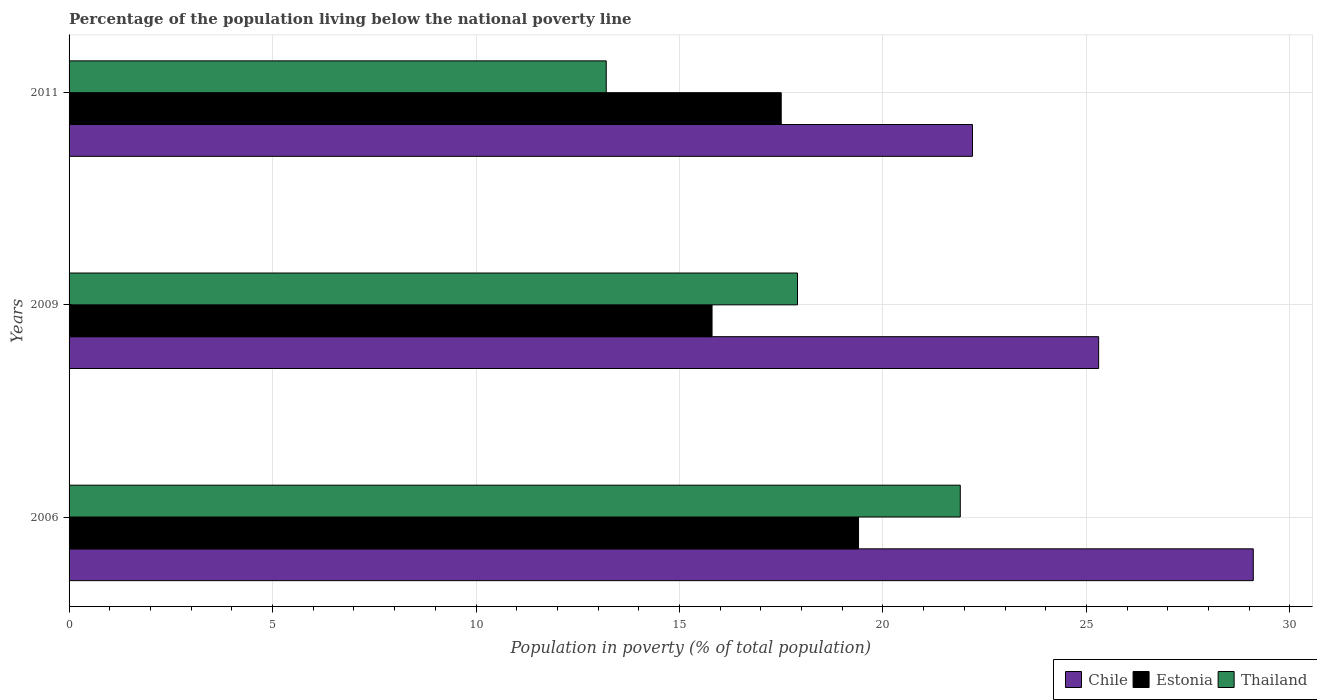How many different coloured bars are there?
Offer a terse response. 3. How many groups of bars are there?
Provide a short and direct response. 3. Are the number of bars per tick equal to the number of legend labels?
Offer a very short reply. Yes. Are the number of bars on each tick of the Y-axis equal?
Your response must be concise. Yes. How many bars are there on the 1st tick from the bottom?
Your answer should be very brief. 3. What is the label of the 1st group of bars from the top?
Your answer should be compact. 2011. In how many cases, is the number of bars for a given year not equal to the number of legend labels?
Provide a short and direct response. 0. Across all years, what is the maximum percentage of the population living below the national poverty line in Thailand?
Keep it short and to the point. 21.9. What is the total percentage of the population living below the national poverty line in Thailand in the graph?
Provide a succinct answer. 53. What is the difference between the percentage of the population living below the national poverty line in Thailand in 2006 and that in 2009?
Ensure brevity in your answer.  4. What is the difference between the percentage of the population living below the national poverty line in Thailand in 2006 and the percentage of the population living below the national poverty line in Estonia in 2011?
Provide a succinct answer. 4.4. What is the average percentage of the population living below the national poverty line in Estonia per year?
Make the answer very short. 17.57. In the year 2011, what is the difference between the percentage of the population living below the national poverty line in Chile and percentage of the population living below the national poverty line in Estonia?
Offer a very short reply. 4.7. In how many years, is the percentage of the population living below the national poverty line in Chile greater than 19 %?
Offer a terse response. 3. What is the ratio of the percentage of the population living below the national poverty line in Thailand in 2009 to that in 2011?
Offer a terse response. 1.36. Is the percentage of the population living below the national poverty line in Chile in 2006 less than that in 2011?
Give a very brief answer. No. Is the difference between the percentage of the population living below the national poverty line in Chile in 2009 and 2011 greater than the difference between the percentage of the population living below the national poverty line in Estonia in 2009 and 2011?
Offer a very short reply. Yes. What is the difference between the highest and the second highest percentage of the population living below the national poverty line in Estonia?
Your answer should be very brief. 1.9. In how many years, is the percentage of the population living below the national poverty line in Thailand greater than the average percentage of the population living below the national poverty line in Thailand taken over all years?
Provide a succinct answer. 2. What does the 1st bar from the top in 2011 represents?
Keep it short and to the point. Thailand. What does the 1st bar from the bottom in 2009 represents?
Ensure brevity in your answer.  Chile. Is it the case that in every year, the sum of the percentage of the population living below the national poverty line in Thailand and percentage of the population living below the national poverty line in Estonia is greater than the percentage of the population living below the national poverty line in Chile?
Give a very brief answer. Yes. How many bars are there?
Your response must be concise. 9. Are the values on the major ticks of X-axis written in scientific E-notation?
Your answer should be very brief. No. How are the legend labels stacked?
Keep it short and to the point. Horizontal. What is the title of the graph?
Your response must be concise. Percentage of the population living below the national poverty line. Does "Portugal" appear as one of the legend labels in the graph?
Ensure brevity in your answer.  No. What is the label or title of the X-axis?
Provide a short and direct response. Population in poverty (% of total population). What is the label or title of the Y-axis?
Your answer should be compact. Years. What is the Population in poverty (% of total population) in Chile in 2006?
Your answer should be very brief. 29.1. What is the Population in poverty (% of total population) in Thailand in 2006?
Ensure brevity in your answer.  21.9. What is the Population in poverty (% of total population) in Chile in 2009?
Provide a short and direct response. 25.3. What is the Population in poverty (% of total population) in Estonia in 2011?
Offer a terse response. 17.5. Across all years, what is the maximum Population in poverty (% of total population) of Chile?
Give a very brief answer. 29.1. Across all years, what is the maximum Population in poverty (% of total population) of Estonia?
Provide a succinct answer. 19.4. Across all years, what is the maximum Population in poverty (% of total population) of Thailand?
Ensure brevity in your answer.  21.9. Across all years, what is the minimum Population in poverty (% of total population) of Estonia?
Your answer should be very brief. 15.8. Across all years, what is the minimum Population in poverty (% of total population) of Thailand?
Provide a short and direct response. 13.2. What is the total Population in poverty (% of total population) of Chile in the graph?
Make the answer very short. 76.6. What is the total Population in poverty (% of total population) of Estonia in the graph?
Give a very brief answer. 52.7. What is the difference between the Population in poverty (% of total population) of Chile in 2006 and that in 2009?
Your answer should be very brief. 3.8. What is the difference between the Population in poverty (% of total population) of Chile in 2006 and that in 2011?
Offer a very short reply. 6.9. What is the difference between the Population in poverty (% of total population) in Thailand in 2006 and that in 2011?
Make the answer very short. 8.7. What is the difference between the Population in poverty (% of total population) in Estonia in 2009 and that in 2011?
Give a very brief answer. -1.7. What is the difference between the Population in poverty (% of total population) in Chile in 2006 and the Population in poverty (% of total population) in Thailand in 2011?
Offer a terse response. 15.9. What is the difference between the Population in poverty (% of total population) in Estonia in 2006 and the Population in poverty (% of total population) in Thailand in 2011?
Offer a very short reply. 6.2. What is the difference between the Population in poverty (% of total population) in Chile in 2009 and the Population in poverty (% of total population) in Estonia in 2011?
Your answer should be very brief. 7.8. What is the difference between the Population in poverty (% of total population) in Chile in 2009 and the Population in poverty (% of total population) in Thailand in 2011?
Make the answer very short. 12.1. What is the difference between the Population in poverty (% of total population) in Estonia in 2009 and the Population in poverty (% of total population) in Thailand in 2011?
Offer a terse response. 2.6. What is the average Population in poverty (% of total population) in Chile per year?
Offer a very short reply. 25.53. What is the average Population in poverty (% of total population) in Estonia per year?
Your response must be concise. 17.57. What is the average Population in poverty (% of total population) of Thailand per year?
Your answer should be very brief. 17.67. In the year 2006, what is the difference between the Population in poverty (% of total population) of Chile and Population in poverty (% of total population) of Thailand?
Ensure brevity in your answer.  7.2. In the year 2011, what is the difference between the Population in poverty (% of total population) in Chile and Population in poverty (% of total population) in Estonia?
Your response must be concise. 4.7. In the year 2011, what is the difference between the Population in poverty (% of total population) in Chile and Population in poverty (% of total population) in Thailand?
Offer a terse response. 9. In the year 2011, what is the difference between the Population in poverty (% of total population) of Estonia and Population in poverty (% of total population) of Thailand?
Provide a succinct answer. 4.3. What is the ratio of the Population in poverty (% of total population) of Chile in 2006 to that in 2009?
Make the answer very short. 1.15. What is the ratio of the Population in poverty (% of total population) in Estonia in 2006 to that in 2009?
Your answer should be compact. 1.23. What is the ratio of the Population in poverty (% of total population) of Thailand in 2006 to that in 2009?
Provide a short and direct response. 1.22. What is the ratio of the Population in poverty (% of total population) in Chile in 2006 to that in 2011?
Offer a terse response. 1.31. What is the ratio of the Population in poverty (% of total population) in Estonia in 2006 to that in 2011?
Keep it short and to the point. 1.11. What is the ratio of the Population in poverty (% of total population) of Thailand in 2006 to that in 2011?
Give a very brief answer. 1.66. What is the ratio of the Population in poverty (% of total population) of Chile in 2009 to that in 2011?
Offer a terse response. 1.14. What is the ratio of the Population in poverty (% of total population) in Estonia in 2009 to that in 2011?
Provide a succinct answer. 0.9. What is the ratio of the Population in poverty (% of total population) in Thailand in 2009 to that in 2011?
Offer a terse response. 1.36. What is the difference between the highest and the second highest Population in poverty (% of total population) in Estonia?
Offer a very short reply. 1.9. 